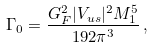Convert formula to latex. <formula><loc_0><loc_0><loc_500><loc_500>\Gamma _ { 0 } = \frac { G _ { F } ^ { 2 } | V _ { u s } | ^ { 2 } M _ { 1 } ^ { 5 } } { 1 9 2 \pi ^ { 3 } } \, ,</formula> 